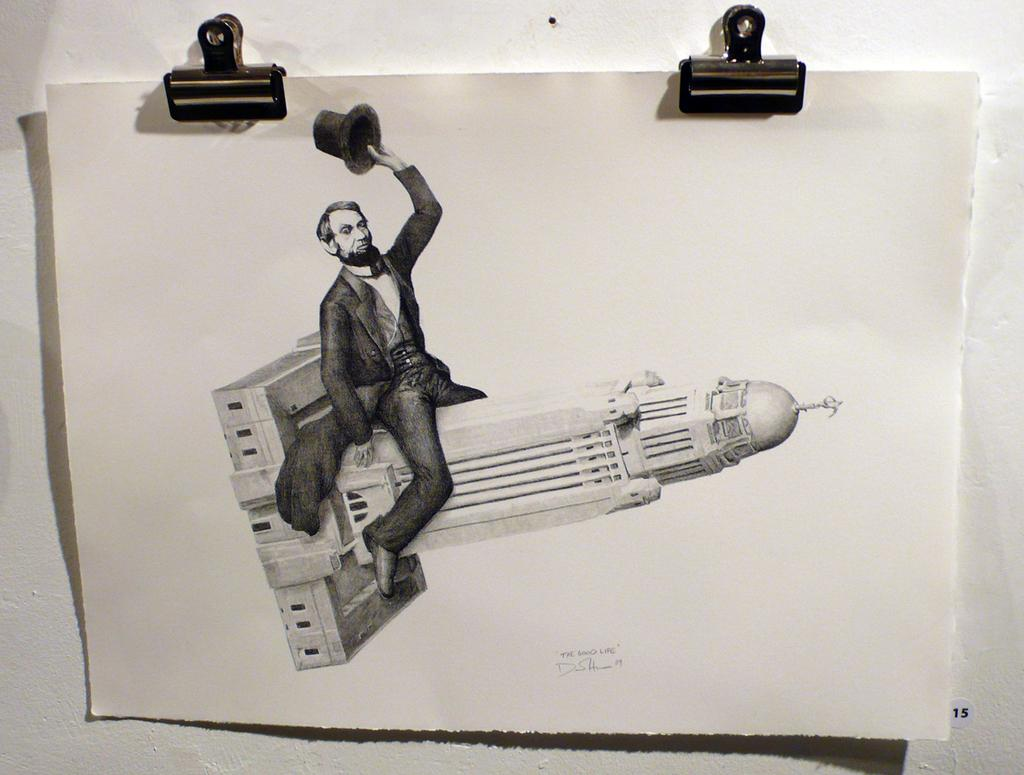What is depicted on the paper in the image? The paper contains an art of a man. What is the man in the art holding? The man in the art is holding a hat in his hand. Where is the man in the art sitting? The man in the art is sitting on a building. How is the paper with the art attached to the wall? Paper clips are used to hang the paper on the wall. How many letters are visible in the art on the paper? There are no letters visible in the art on the paper; it is an image of a man holding a hat and sitting on a building. 